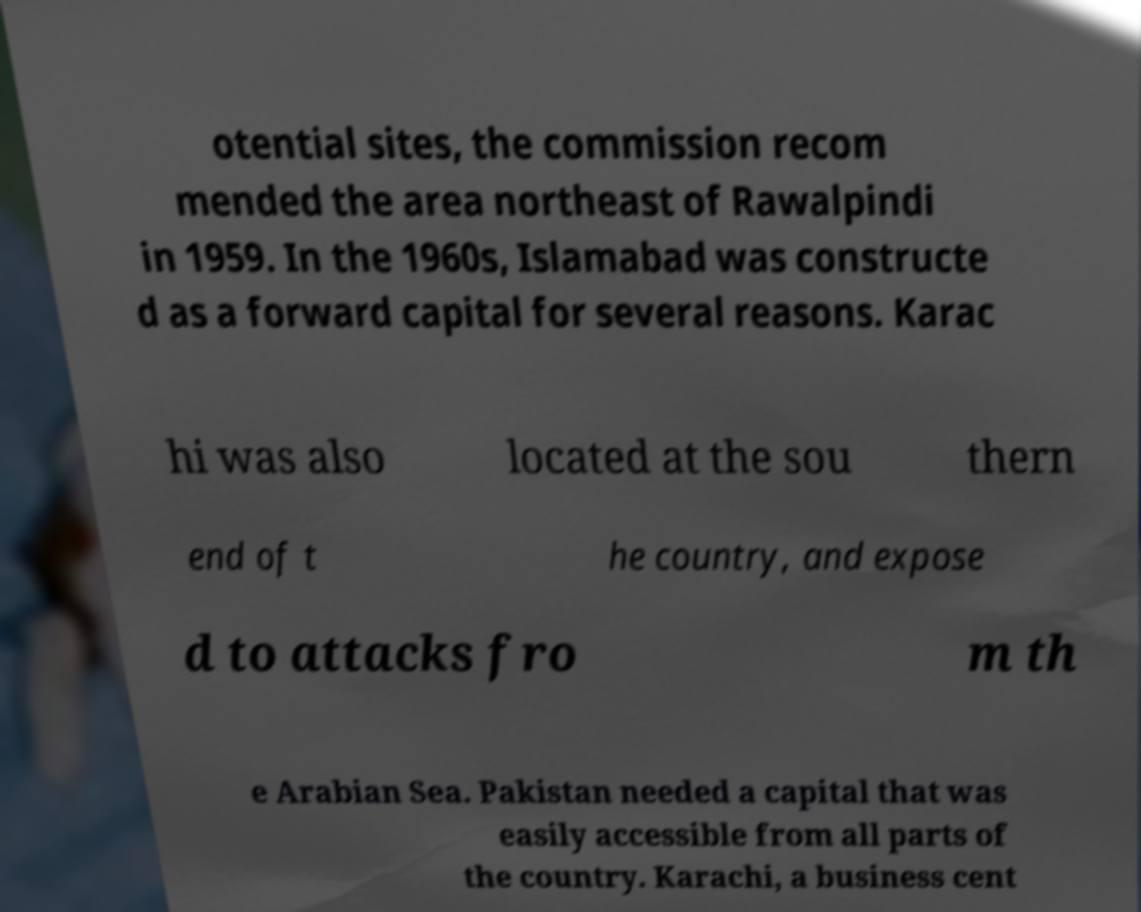For documentation purposes, I need the text within this image transcribed. Could you provide that? otential sites, the commission recom mended the area northeast of Rawalpindi in 1959. In the 1960s, Islamabad was constructe d as a forward capital for several reasons. Karac hi was also located at the sou thern end of t he country, and expose d to attacks fro m th e Arabian Sea. Pakistan needed a capital that was easily accessible from all parts of the country. Karachi, a business cent 